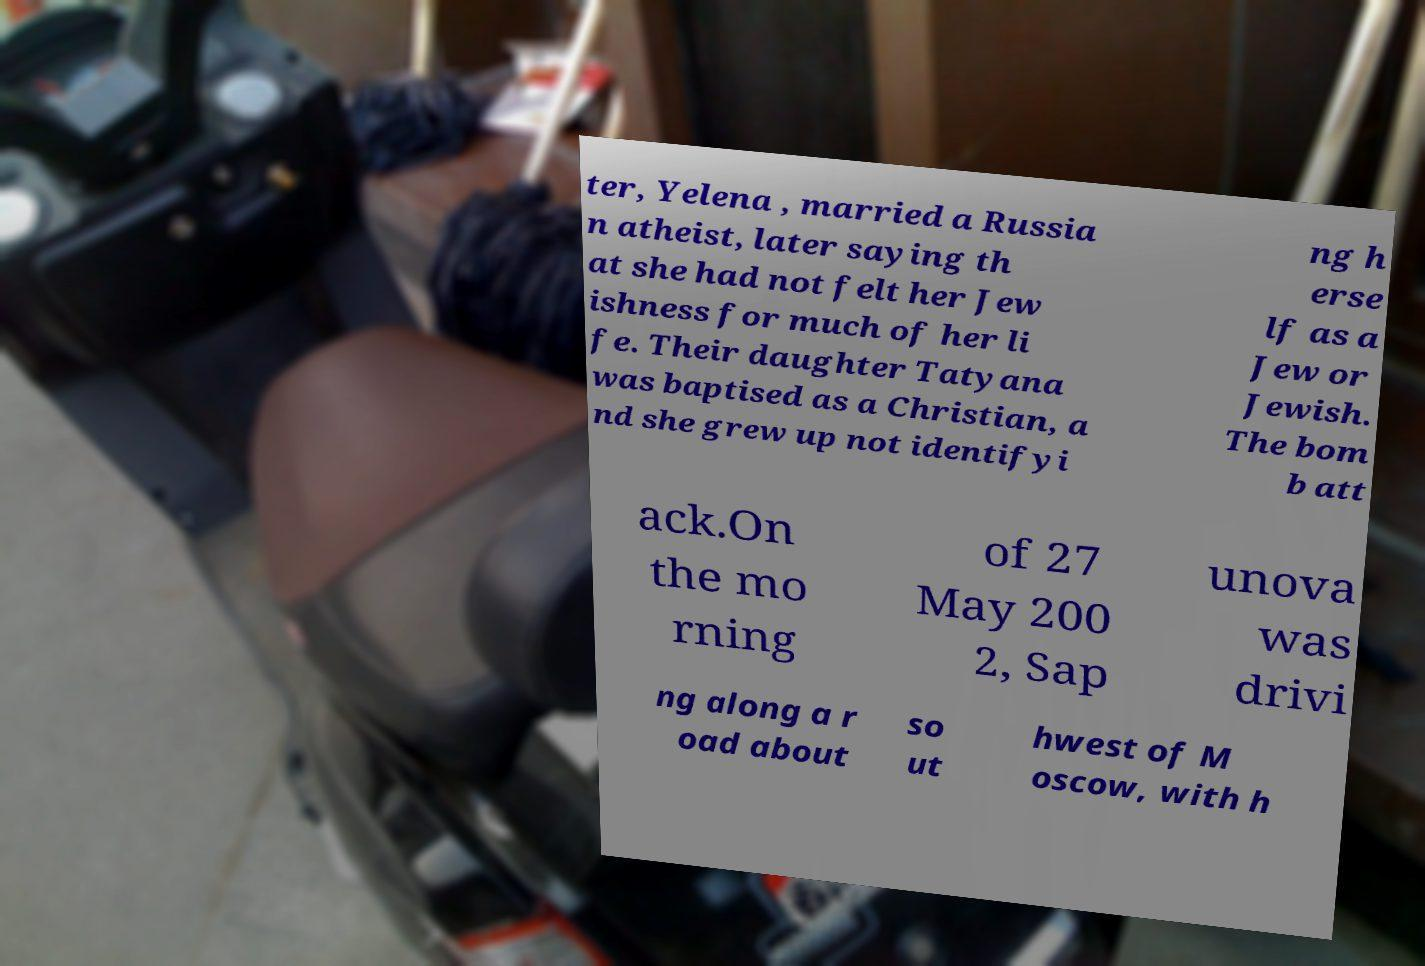Could you extract and type out the text from this image? ter, Yelena , married a Russia n atheist, later saying th at she had not felt her Jew ishness for much of her li fe. Their daughter Tatyana was baptised as a Christian, a nd she grew up not identifyi ng h erse lf as a Jew or Jewish. The bom b att ack.On the mo rning of 27 May 200 2, Sap unova was drivi ng along a r oad about so ut hwest of M oscow, with h 